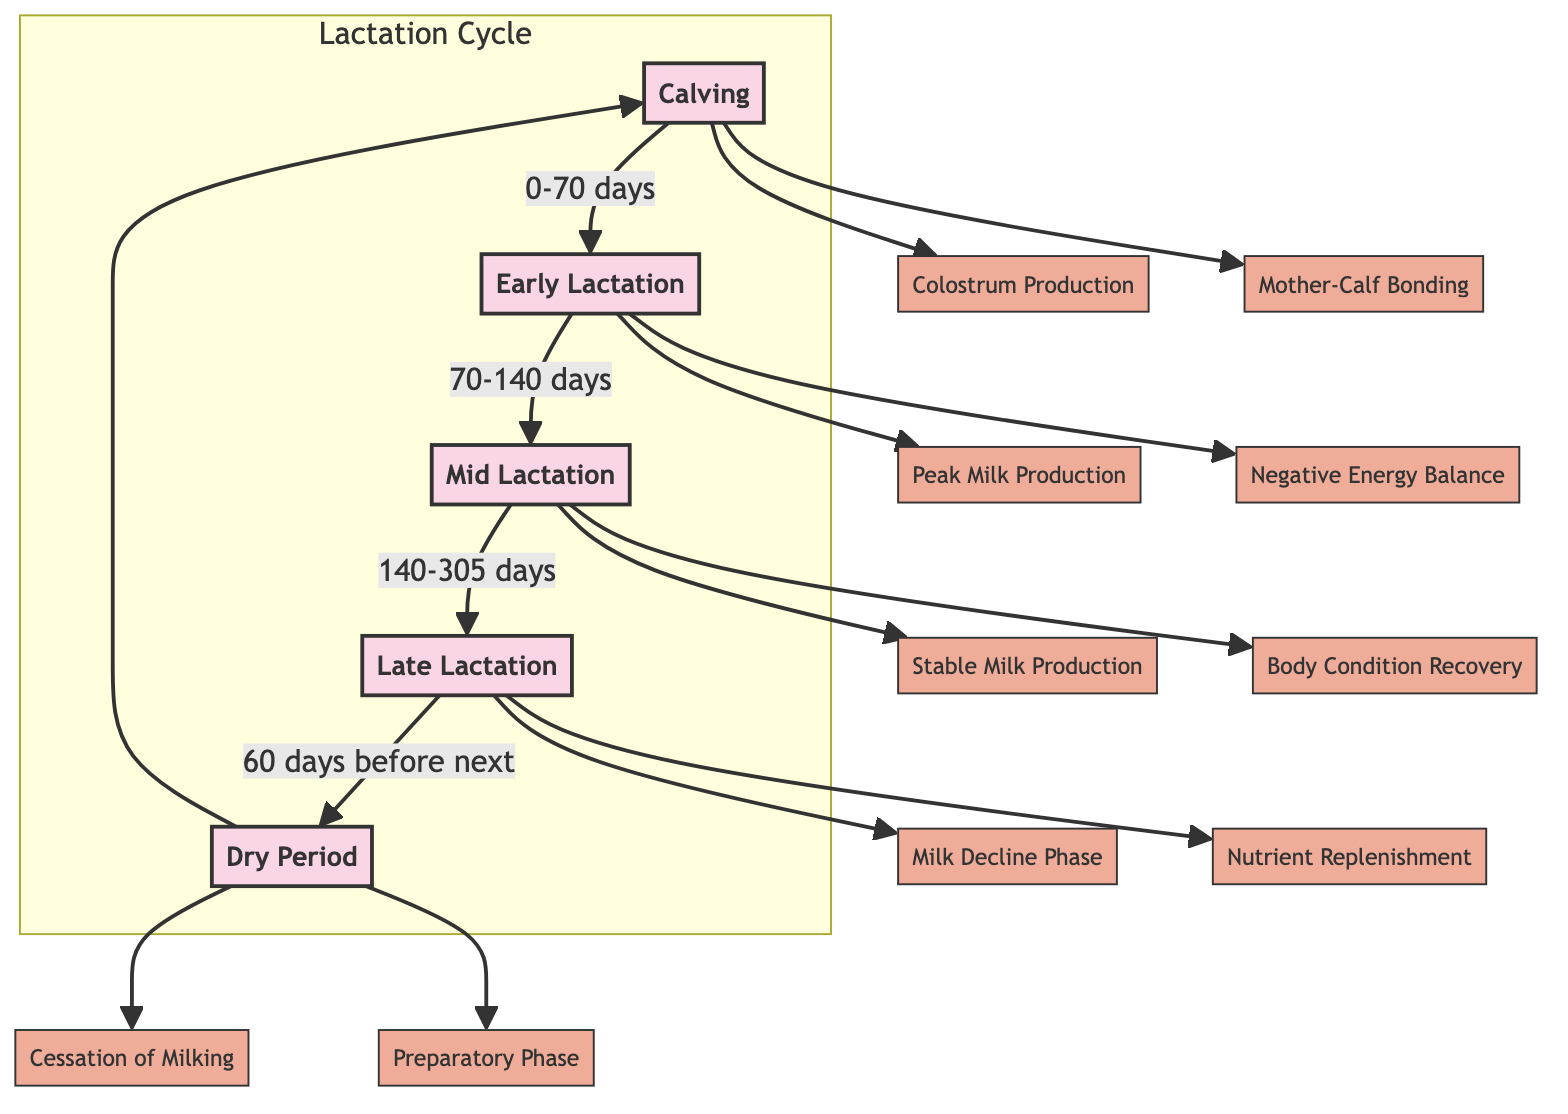What is the first stage of lactation? The diagram starts with the node labeled "C" for Calving, which is the first stage of the lactation cycle.
Answer: Calving How many main stages are there in the lactation cycle? The diagram lists five stages: Calving, Early Lactation, Mid Lactation, Late Lactation, and Dry Period. Therefore, the number of main stages is five.
Answer: 5 What happens during the Early Lactation phase? The Early Lactation phase involves milestones such as Peak Milk Production and Negative Energy Balance, which are indicated in the diagram.
Answer: Peak Milk Production, Negative Energy Balance What is the duration of the Mid Lactation stage? The diagram specifies that Mid Lactation lasts from 140 to 305 days, making this a span of 165 days.
Answer: 165 days Identify a milestone that occurs during the Late Lactation phase. The diagram shows two milestones under Late Lactation: Milk Decline Phase and Nutrient Replenishment. These are identified nodes stemming from Late Lactation.
Answer: Milk Decline Phase, Nutrient Replenishment Which stage comes after the Dry Period? According to the diagram, the Dry Period (DP) points back to Calving (C), indicating that Calving follows the Dry Period in the cycle.
Answer: Calving What is the relationship between Early Lactation and Mid Lactation? The diagram indicates a directional flow from Early Lactation (EL) to Mid Lactation (ML), which shows that Mid Lactation follows Early Lactation.
Answer: Early Lactation leads to Mid Lactation What is the last milestone before entering the next Dry Period? Prior to the Dry Period, the milestone listed is the Cessation of Milking, which refers to the cessation of milk production as indicated in the diagram.
Answer: Cessation of Milking What phase lasts for 60 days before the next calving? The diagram indicates that the Dry Period lasts 60 days before transitioning back to Calving.
Answer: 60 days 